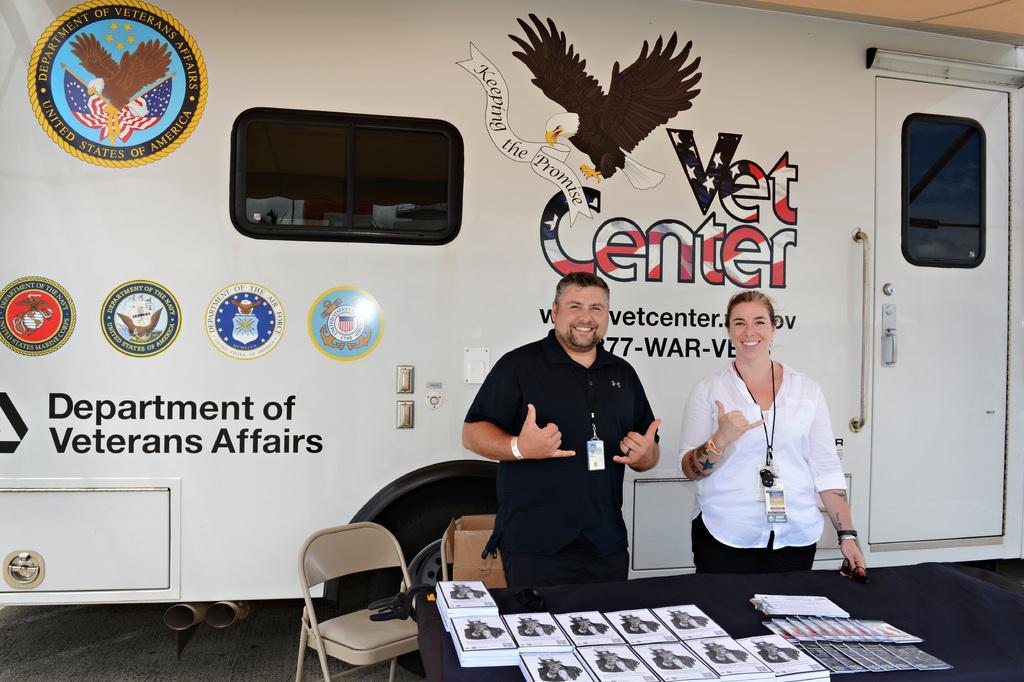Could you give a brief overview of what you see in this image? In the center of the image we can see a man and a lady standing and smiling, before them there is a table and we can see books placed on the table. There are chairs and we can see a cardboard box. In the background there is a door and we can see a board. 